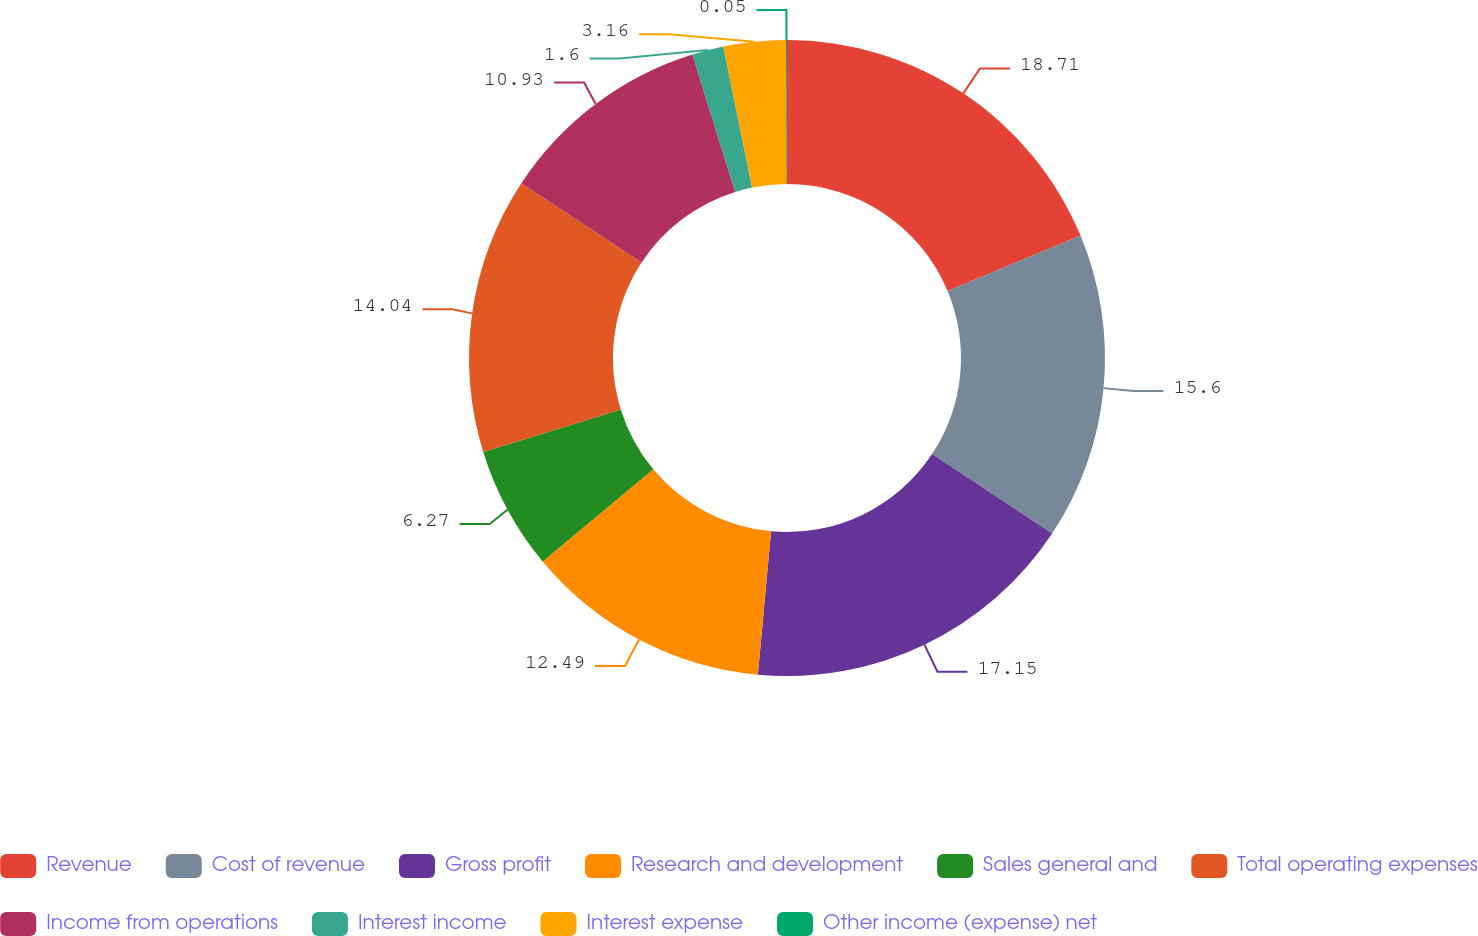<chart> <loc_0><loc_0><loc_500><loc_500><pie_chart><fcel>Revenue<fcel>Cost of revenue<fcel>Gross profit<fcel>Research and development<fcel>Sales general and<fcel>Total operating expenses<fcel>Income from operations<fcel>Interest income<fcel>Interest expense<fcel>Other income (expense) net<nl><fcel>18.71%<fcel>15.6%<fcel>17.15%<fcel>12.49%<fcel>6.27%<fcel>14.04%<fcel>10.93%<fcel>1.6%<fcel>3.16%<fcel>0.05%<nl></chart> 